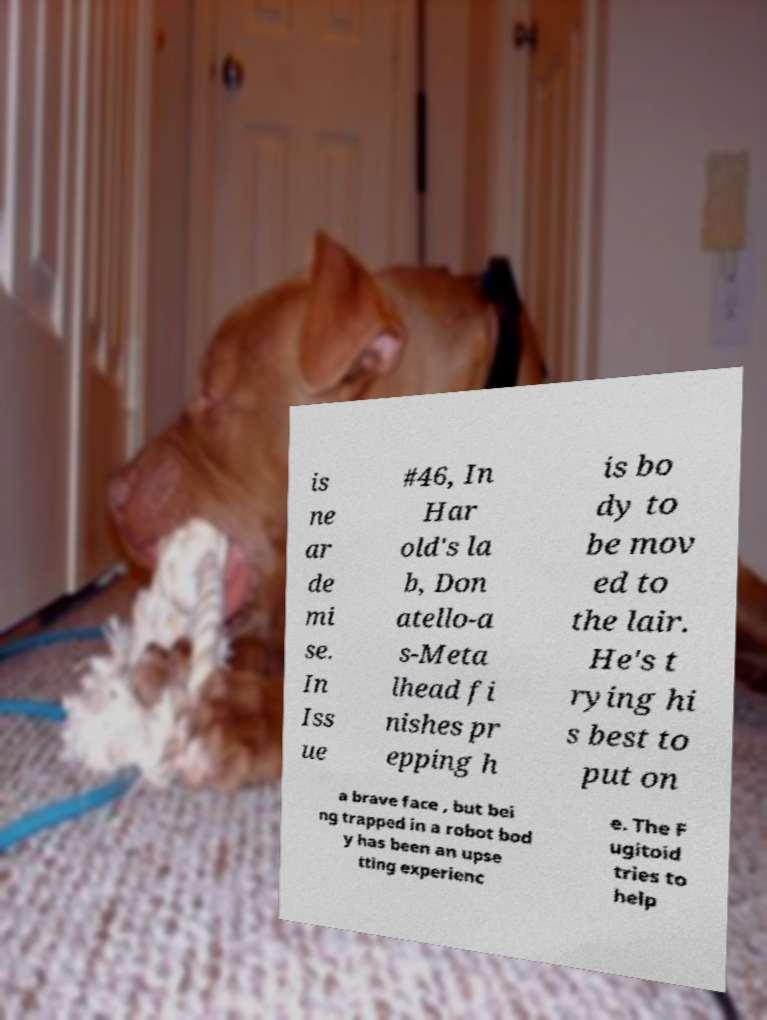Could you assist in decoding the text presented in this image and type it out clearly? is ne ar de mi se. In Iss ue #46, In Har old's la b, Don atello-a s-Meta lhead fi nishes pr epping h is bo dy to be mov ed to the lair. He's t rying hi s best to put on a brave face , but bei ng trapped in a robot bod y has been an upse tting experienc e. The F ugitoid tries to help 